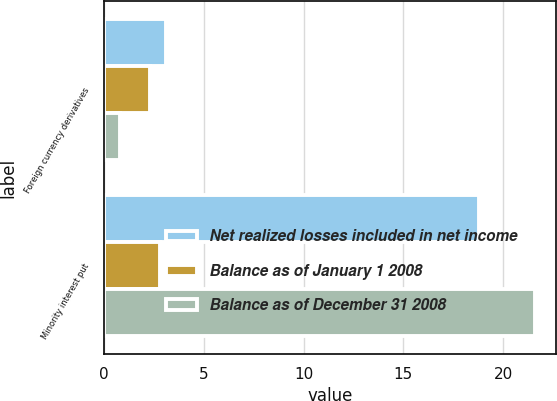Convert chart. <chart><loc_0><loc_0><loc_500><loc_500><stacked_bar_chart><ecel><fcel>Foreign currency derivatives<fcel>Minority interest put<nl><fcel>Net realized losses included in net income<fcel>3.1<fcel>18.8<nl><fcel>Balance as of January 1 2008<fcel>2.3<fcel>2.8<nl><fcel>Balance as of December 31 2008<fcel>0.8<fcel>21.6<nl></chart> 